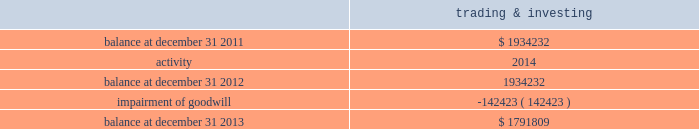Note 9 2014goodwill and other intangibles , net goodwill the table outlines the activity in the carrying value of the company 2019s goodwill , which is all assigned to the company 2019s trading and investing segment ( dollars in thousands ) : .
Goodwill is evaluated for impairment on an annual basis and when events or changes indicate the carrying value of an asset exceeds its fair value and the loss may not be recoverable .
At december 31 , 2013 and 2012 , the company 2019s trading and investing segment had two reporting units ; market making and retail brokerage .
At the end of june 2013 , the company decided to exit its market making business .
Based on this decision in the second quarter of 2013 , the company conducted an interim goodwill impairment test for the market making reporting unit , using the expected sale structure of the market making business .
This structure assumed a shorter period of cash flows related to an order flow arrangement , compared to prior estimates of fair value .
Based on the results of the first step of the goodwill impairment test , the company determined that the carrying value of the market making reporting unit , including goodwill , exceeded the fair value for that reporting unit as of june 30 , 2013 .
The company proceeded to the second step of the goodwill impairment test to measure the amount of goodwill impairment .
As a result of the evaluation , it was determined that the entire carrying amount of goodwill allocated to the market making reporting unit was impaired , and the company recognized a $ 142.4 million impairment of goodwill during the second quarter of 2013 .
For the year ended december 31 , 2013 , the company performed its annual goodwill assessment for the retail brokerage reporting unit , electing to qualitatively assess whether it was more likely than not that the fair value was less than the carrying value .
As a result of this assessment , the company determined that the first step of the goodwill impairment test was not necessary , and concluded that goodwill was not impaired at december 31 , 2013 .
At december 31 , 2013 , goodwill is net of accumulated impairment losses of $ 142.4 million related to the trading and investing segment and $ 101.2 million in the balance sheet management segment .
At december 31 , 2012 , goodwill is net of accumulated impairment losses of $ 101.2 million in the balance sheet management segment. .
What was the percentage change in carrying value of the company 2019s goodwill between 2012 and 2013? 
Computations: (-142423 / 1934232)
Answer: -0.07363. 